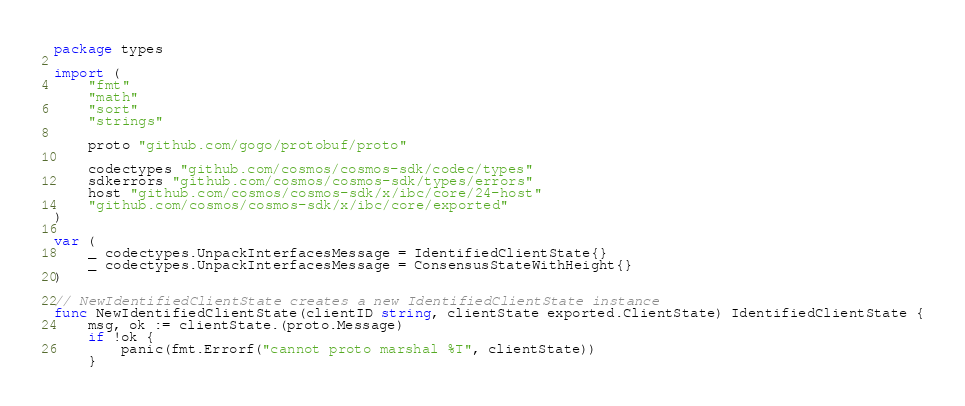Convert code to text. <code><loc_0><loc_0><loc_500><loc_500><_Go_>package types

import (
	"fmt"
	"math"
	"sort"
	"strings"

	proto "github.com/gogo/protobuf/proto"

	codectypes "github.com/cosmos/cosmos-sdk/codec/types"
	sdkerrors "github.com/cosmos/cosmos-sdk/types/errors"
	host "github.com/cosmos/cosmos-sdk/x/ibc/core/24-host"
	"github.com/cosmos/cosmos-sdk/x/ibc/core/exported"
)

var (
	_ codectypes.UnpackInterfacesMessage = IdentifiedClientState{}
	_ codectypes.UnpackInterfacesMessage = ConsensusStateWithHeight{}
)

// NewIdentifiedClientState creates a new IdentifiedClientState instance
func NewIdentifiedClientState(clientID string, clientState exported.ClientState) IdentifiedClientState {
	msg, ok := clientState.(proto.Message)
	if !ok {
		panic(fmt.Errorf("cannot proto marshal %T", clientState))
	}
</code> 